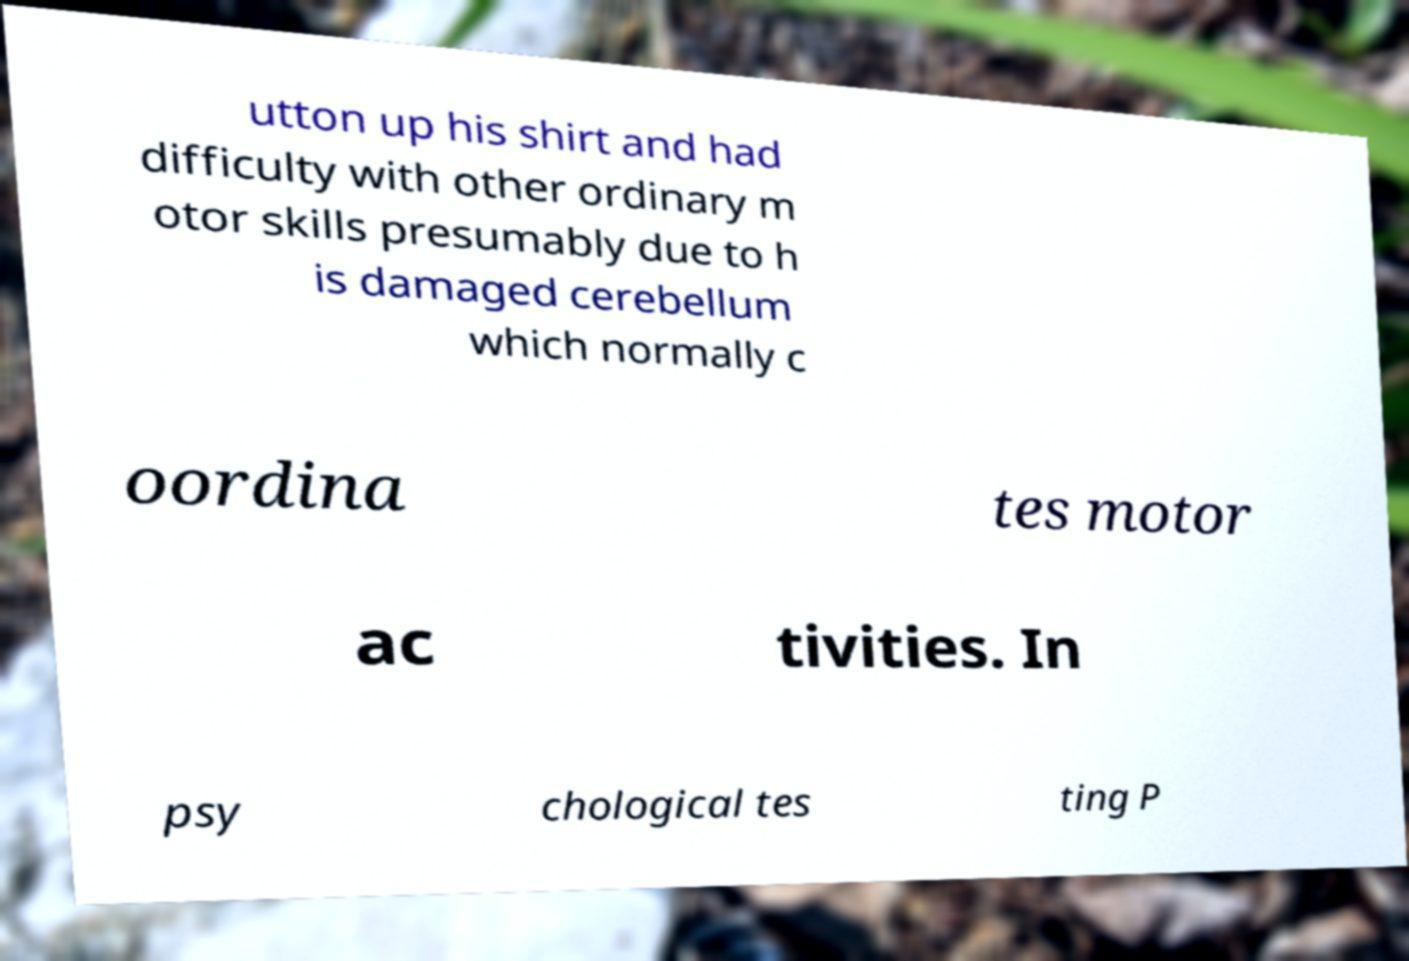Can you accurately transcribe the text from the provided image for me? utton up his shirt and had difficulty with other ordinary m otor skills presumably due to h is damaged cerebellum which normally c oordina tes motor ac tivities. In psy chological tes ting P 